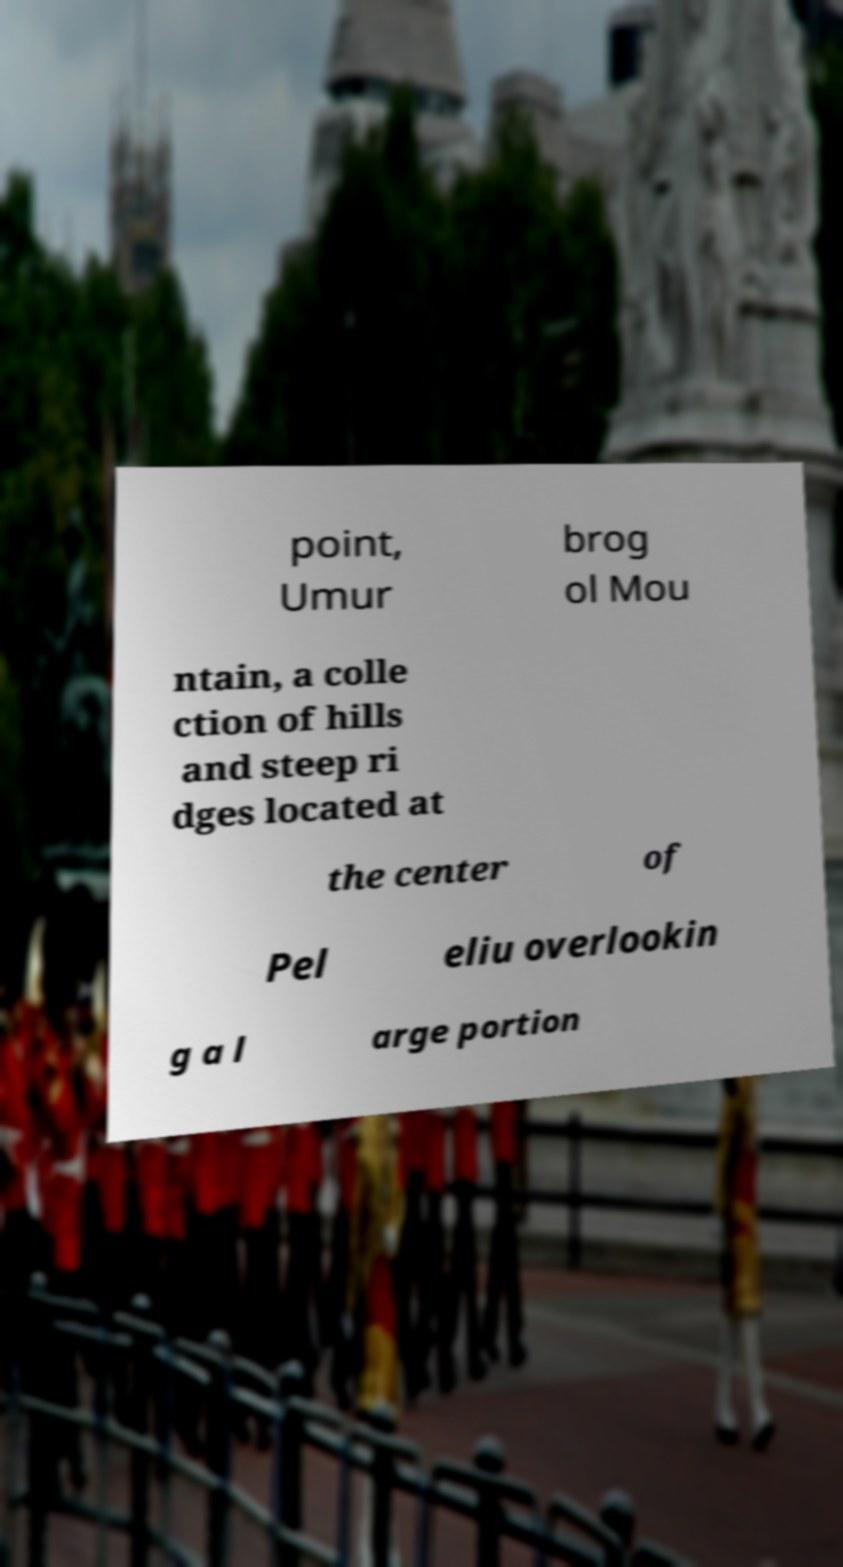Please identify and transcribe the text found in this image. point, Umur brog ol Mou ntain, a colle ction of hills and steep ri dges located at the center of Pel eliu overlookin g a l arge portion 